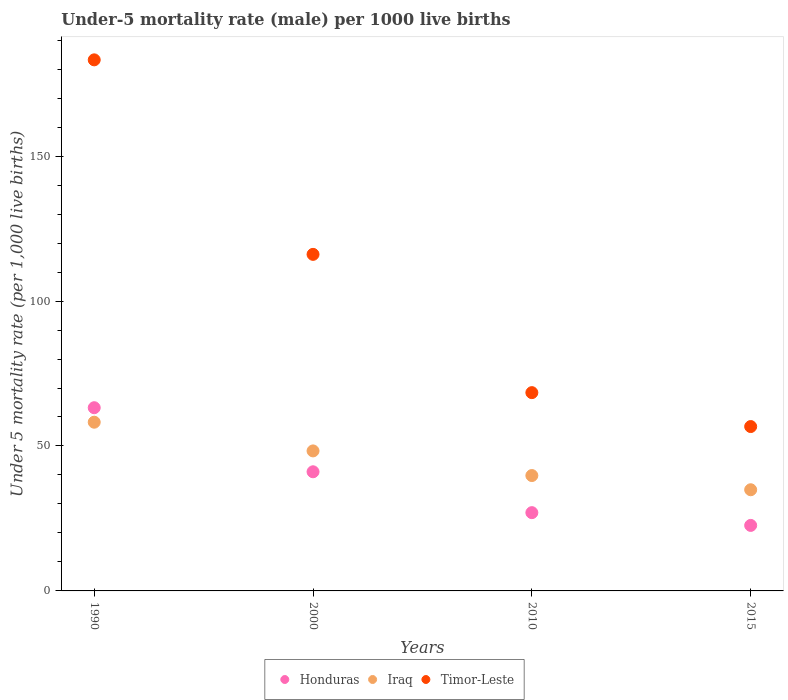Is the number of dotlines equal to the number of legend labels?
Make the answer very short. Yes. What is the under-five mortality rate in Iraq in 2015?
Your answer should be very brief. 34.9. Across all years, what is the maximum under-five mortality rate in Iraq?
Your response must be concise. 58.2. Across all years, what is the minimum under-five mortality rate in Iraq?
Ensure brevity in your answer.  34.9. In which year was the under-five mortality rate in Honduras minimum?
Your answer should be compact. 2015. What is the total under-five mortality rate in Honduras in the graph?
Offer a very short reply. 153.9. What is the difference between the under-five mortality rate in Iraq in 2000 and that in 2010?
Your answer should be compact. 8.5. What is the difference between the under-five mortality rate in Timor-Leste in 1990 and the under-five mortality rate in Honduras in 2000?
Your answer should be very brief. 142.1. What is the average under-five mortality rate in Honduras per year?
Offer a terse response. 38.48. In the year 2000, what is the difference between the under-five mortality rate in Honduras and under-five mortality rate in Timor-Leste?
Ensure brevity in your answer.  -75. In how many years, is the under-five mortality rate in Iraq greater than 110?
Provide a succinct answer. 0. What is the ratio of the under-five mortality rate in Honduras in 1990 to that in 2010?
Your answer should be compact. 2.34. Is the under-five mortality rate in Honduras in 2010 less than that in 2015?
Your answer should be compact. No. What is the difference between the highest and the second highest under-five mortality rate in Iraq?
Your response must be concise. 9.9. What is the difference between the highest and the lowest under-five mortality rate in Honduras?
Offer a terse response. 40.6. In how many years, is the under-five mortality rate in Honduras greater than the average under-five mortality rate in Honduras taken over all years?
Your answer should be compact. 2. Is the sum of the under-five mortality rate in Timor-Leste in 1990 and 2010 greater than the maximum under-five mortality rate in Iraq across all years?
Give a very brief answer. Yes. Does the under-five mortality rate in Timor-Leste monotonically increase over the years?
Your answer should be very brief. No. Is the under-five mortality rate in Iraq strictly less than the under-five mortality rate in Honduras over the years?
Give a very brief answer. No. How many dotlines are there?
Your answer should be very brief. 3. Are the values on the major ticks of Y-axis written in scientific E-notation?
Your answer should be compact. No. Does the graph contain any zero values?
Your answer should be compact. No. How many legend labels are there?
Provide a short and direct response. 3. How are the legend labels stacked?
Ensure brevity in your answer.  Horizontal. What is the title of the graph?
Give a very brief answer. Under-5 mortality rate (male) per 1000 live births. Does "High income: OECD" appear as one of the legend labels in the graph?
Ensure brevity in your answer.  No. What is the label or title of the Y-axis?
Make the answer very short. Under 5 mortality rate (per 1,0 live births). What is the Under 5 mortality rate (per 1,000 live births) of Honduras in 1990?
Offer a very short reply. 63.2. What is the Under 5 mortality rate (per 1,000 live births) of Iraq in 1990?
Provide a succinct answer. 58.2. What is the Under 5 mortality rate (per 1,000 live births) in Timor-Leste in 1990?
Offer a very short reply. 183.2. What is the Under 5 mortality rate (per 1,000 live births) of Honduras in 2000?
Keep it short and to the point. 41.1. What is the Under 5 mortality rate (per 1,000 live births) of Iraq in 2000?
Make the answer very short. 48.3. What is the Under 5 mortality rate (per 1,000 live births) of Timor-Leste in 2000?
Offer a very short reply. 116.1. What is the Under 5 mortality rate (per 1,000 live births) in Honduras in 2010?
Your response must be concise. 27. What is the Under 5 mortality rate (per 1,000 live births) of Iraq in 2010?
Your answer should be compact. 39.8. What is the Under 5 mortality rate (per 1,000 live births) in Timor-Leste in 2010?
Keep it short and to the point. 68.4. What is the Under 5 mortality rate (per 1,000 live births) of Honduras in 2015?
Ensure brevity in your answer.  22.6. What is the Under 5 mortality rate (per 1,000 live births) in Iraq in 2015?
Keep it short and to the point. 34.9. What is the Under 5 mortality rate (per 1,000 live births) in Timor-Leste in 2015?
Make the answer very short. 56.7. Across all years, what is the maximum Under 5 mortality rate (per 1,000 live births) in Honduras?
Make the answer very short. 63.2. Across all years, what is the maximum Under 5 mortality rate (per 1,000 live births) of Iraq?
Your answer should be very brief. 58.2. Across all years, what is the maximum Under 5 mortality rate (per 1,000 live births) of Timor-Leste?
Keep it short and to the point. 183.2. Across all years, what is the minimum Under 5 mortality rate (per 1,000 live births) of Honduras?
Make the answer very short. 22.6. Across all years, what is the minimum Under 5 mortality rate (per 1,000 live births) of Iraq?
Provide a succinct answer. 34.9. Across all years, what is the minimum Under 5 mortality rate (per 1,000 live births) of Timor-Leste?
Make the answer very short. 56.7. What is the total Under 5 mortality rate (per 1,000 live births) in Honduras in the graph?
Your answer should be very brief. 153.9. What is the total Under 5 mortality rate (per 1,000 live births) of Iraq in the graph?
Make the answer very short. 181.2. What is the total Under 5 mortality rate (per 1,000 live births) in Timor-Leste in the graph?
Offer a terse response. 424.4. What is the difference between the Under 5 mortality rate (per 1,000 live births) of Honduras in 1990 and that in 2000?
Offer a terse response. 22.1. What is the difference between the Under 5 mortality rate (per 1,000 live births) of Iraq in 1990 and that in 2000?
Ensure brevity in your answer.  9.9. What is the difference between the Under 5 mortality rate (per 1,000 live births) of Timor-Leste in 1990 and that in 2000?
Offer a very short reply. 67.1. What is the difference between the Under 5 mortality rate (per 1,000 live births) in Honduras in 1990 and that in 2010?
Offer a very short reply. 36.2. What is the difference between the Under 5 mortality rate (per 1,000 live births) in Timor-Leste in 1990 and that in 2010?
Give a very brief answer. 114.8. What is the difference between the Under 5 mortality rate (per 1,000 live births) of Honduras in 1990 and that in 2015?
Provide a succinct answer. 40.6. What is the difference between the Under 5 mortality rate (per 1,000 live births) in Iraq in 1990 and that in 2015?
Provide a succinct answer. 23.3. What is the difference between the Under 5 mortality rate (per 1,000 live births) of Timor-Leste in 1990 and that in 2015?
Ensure brevity in your answer.  126.5. What is the difference between the Under 5 mortality rate (per 1,000 live births) of Iraq in 2000 and that in 2010?
Provide a succinct answer. 8.5. What is the difference between the Under 5 mortality rate (per 1,000 live births) in Timor-Leste in 2000 and that in 2010?
Offer a terse response. 47.7. What is the difference between the Under 5 mortality rate (per 1,000 live births) of Iraq in 2000 and that in 2015?
Offer a terse response. 13.4. What is the difference between the Under 5 mortality rate (per 1,000 live births) in Timor-Leste in 2000 and that in 2015?
Offer a terse response. 59.4. What is the difference between the Under 5 mortality rate (per 1,000 live births) in Honduras in 1990 and the Under 5 mortality rate (per 1,000 live births) in Timor-Leste in 2000?
Your answer should be compact. -52.9. What is the difference between the Under 5 mortality rate (per 1,000 live births) of Iraq in 1990 and the Under 5 mortality rate (per 1,000 live births) of Timor-Leste in 2000?
Keep it short and to the point. -57.9. What is the difference between the Under 5 mortality rate (per 1,000 live births) in Honduras in 1990 and the Under 5 mortality rate (per 1,000 live births) in Iraq in 2010?
Your answer should be compact. 23.4. What is the difference between the Under 5 mortality rate (per 1,000 live births) in Iraq in 1990 and the Under 5 mortality rate (per 1,000 live births) in Timor-Leste in 2010?
Make the answer very short. -10.2. What is the difference between the Under 5 mortality rate (per 1,000 live births) of Honduras in 1990 and the Under 5 mortality rate (per 1,000 live births) of Iraq in 2015?
Your answer should be very brief. 28.3. What is the difference between the Under 5 mortality rate (per 1,000 live births) of Honduras in 2000 and the Under 5 mortality rate (per 1,000 live births) of Timor-Leste in 2010?
Your response must be concise. -27.3. What is the difference between the Under 5 mortality rate (per 1,000 live births) in Iraq in 2000 and the Under 5 mortality rate (per 1,000 live births) in Timor-Leste in 2010?
Provide a short and direct response. -20.1. What is the difference between the Under 5 mortality rate (per 1,000 live births) of Honduras in 2000 and the Under 5 mortality rate (per 1,000 live births) of Iraq in 2015?
Provide a succinct answer. 6.2. What is the difference between the Under 5 mortality rate (per 1,000 live births) of Honduras in 2000 and the Under 5 mortality rate (per 1,000 live births) of Timor-Leste in 2015?
Keep it short and to the point. -15.6. What is the difference between the Under 5 mortality rate (per 1,000 live births) in Iraq in 2000 and the Under 5 mortality rate (per 1,000 live births) in Timor-Leste in 2015?
Your answer should be compact. -8.4. What is the difference between the Under 5 mortality rate (per 1,000 live births) of Honduras in 2010 and the Under 5 mortality rate (per 1,000 live births) of Timor-Leste in 2015?
Make the answer very short. -29.7. What is the difference between the Under 5 mortality rate (per 1,000 live births) in Iraq in 2010 and the Under 5 mortality rate (per 1,000 live births) in Timor-Leste in 2015?
Provide a succinct answer. -16.9. What is the average Under 5 mortality rate (per 1,000 live births) of Honduras per year?
Provide a short and direct response. 38.48. What is the average Under 5 mortality rate (per 1,000 live births) in Iraq per year?
Offer a very short reply. 45.3. What is the average Under 5 mortality rate (per 1,000 live births) of Timor-Leste per year?
Ensure brevity in your answer.  106.1. In the year 1990, what is the difference between the Under 5 mortality rate (per 1,000 live births) in Honduras and Under 5 mortality rate (per 1,000 live births) in Timor-Leste?
Your answer should be compact. -120. In the year 1990, what is the difference between the Under 5 mortality rate (per 1,000 live births) in Iraq and Under 5 mortality rate (per 1,000 live births) in Timor-Leste?
Offer a terse response. -125. In the year 2000, what is the difference between the Under 5 mortality rate (per 1,000 live births) of Honduras and Under 5 mortality rate (per 1,000 live births) of Iraq?
Ensure brevity in your answer.  -7.2. In the year 2000, what is the difference between the Under 5 mortality rate (per 1,000 live births) of Honduras and Under 5 mortality rate (per 1,000 live births) of Timor-Leste?
Provide a succinct answer. -75. In the year 2000, what is the difference between the Under 5 mortality rate (per 1,000 live births) of Iraq and Under 5 mortality rate (per 1,000 live births) of Timor-Leste?
Your response must be concise. -67.8. In the year 2010, what is the difference between the Under 5 mortality rate (per 1,000 live births) of Honduras and Under 5 mortality rate (per 1,000 live births) of Timor-Leste?
Offer a very short reply. -41.4. In the year 2010, what is the difference between the Under 5 mortality rate (per 1,000 live births) of Iraq and Under 5 mortality rate (per 1,000 live births) of Timor-Leste?
Your answer should be compact. -28.6. In the year 2015, what is the difference between the Under 5 mortality rate (per 1,000 live births) of Honduras and Under 5 mortality rate (per 1,000 live births) of Timor-Leste?
Make the answer very short. -34.1. In the year 2015, what is the difference between the Under 5 mortality rate (per 1,000 live births) of Iraq and Under 5 mortality rate (per 1,000 live births) of Timor-Leste?
Provide a short and direct response. -21.8. What is the ratio of the Under 5 mortality rate (per 1,000 live births) in Honduras in 1990 to that in 2000?
Offer a terse response. 1.54. What is the ratio of the Under 5 mortality rate (per 1,000 live births) in Iraq in 1990 to that in 2000?
Offer a terse response. 1.21. What is the ratio of the Under 5 mortality rate (per 1,000 live births) of Timor-Leste in 1990 to that in 2000?
Your answer should be compact. 1.58. What is the ratio of the Under 5 mortality rate (per 1,000 live births) of Honduras in 1990 to that in 2010?
Provide a succinct answer. 2.34. What is the ratio of the Under 5 mortality rate (per 1,000 live births) of Iraq in 1990 to that in 2010?
Your response must be concise. 1.46. What is the ratio of the Under 5 mortality rate (per 1,000 live births) of Timor-Leste in 1990 to that in 2010?
Provide a short and direct response. 2.68. What is the ratio of the Under 5 mortality rate (per 1,000 live births) of Honduras in 1990 to that in 2015?
Keep it short and to the point. 2.8. What is the ratio of the Under 5 mortality rate (per 1,000 live births) of Iraq in 1990 to that in 2015?
Ensure brevity in your answer.  1.67. What is the ratio of the Under 5 mortality rate (per 1,000 live births) of Timor-Leste in 1990 to that in 2015?
Your response must be concise. 3.23. What is the ratio of the Under 5 mortality rate (per 1,000 live births) in Honduras in 2000 to that in 2010?
Ensure brevity in your answer.  1.52. What is the ratio of the Under 5 mortality rate (per 1,000 live births) of Iraq in 2000 to that in 2010?
Your response must be concise. 1.21. What is the ratio of the Under 5 mortality rate (per 1,000 live births) in Timor-Leste in 2000 to that in 2010?
Provide a short and direct response. 1.7. What is the ratio of the Under 5 mortality rate (per 1,000 live births) of Honduras in 2000 to that in 2015?
Keep it short and to the point. 1.82. What is the ratio of the Under 5 mortality rate (per 1,000 live births) of Iraq in 2000 to that in 2015?
Your answer should be compact. 1.38. What is the ratio of the Under 5 mortality rate (per 1,000 live births) of Timor-Leste in 2000 to that in 2015?
Keep it short and to the point. 2.05. What is the ratio of the Under 5 mortality rate (per 1,000 live births) in Honduras in 2010 to that in 2015?
Your answer should be compact. 1.19. What is the ratio of the Under 5 mortality rate (per 1,000 live births) of Iraq in 2010 to that in 2015?
Offer a terse response. 1.14. What is the ratio of the Under 5 mortality rate (per 1,000 live births) of Timor-Leste in 2010 to that in 2015?
Give a very brief answer. 1.21. What is the difference between the highest and the second highest Under 5 mortality rate (per 1,000 live births) of Honduras?
Offer a terse response. 22.1. What is the difference between the highest and the second highest Under 5 mortality rate (per 1,000 live births) in Iraq?
Ensure brevity in your answer.  9.9. What is the difference between the highest and the second highest Under 5 mortality rate (per 1,000 live births) in Timor-Leste?
Provide a succinct answer. 67.1. What is the difference between the highest and the lowest Under 5 mortality rate (per 1,000 live births) of Honduras?
Ensure brevity in your answer.  40.6. What is the difference between the highest and the lowest Under 5 mortality rate (per 1,000 live births) of Iraq?
Your answer should be very brief. 23.3. What is the difference between the highest and the lowest Under 5 mortality rate (per 1,000 live births) in Timor-Leste?
Offer a very short reply. 126.5. 